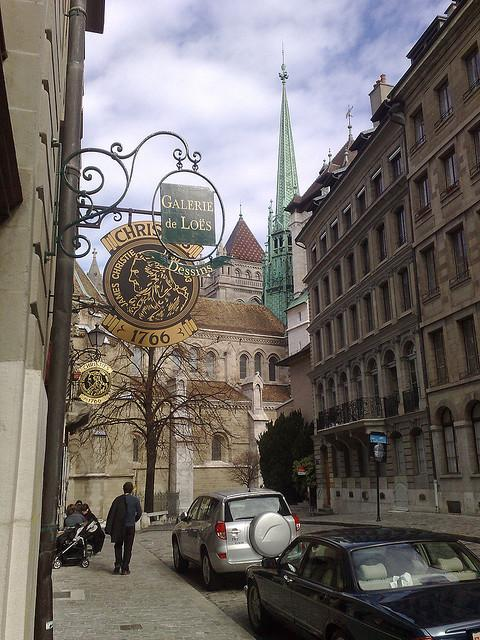Where is there most likely to be a baby at in this picture? stroller 